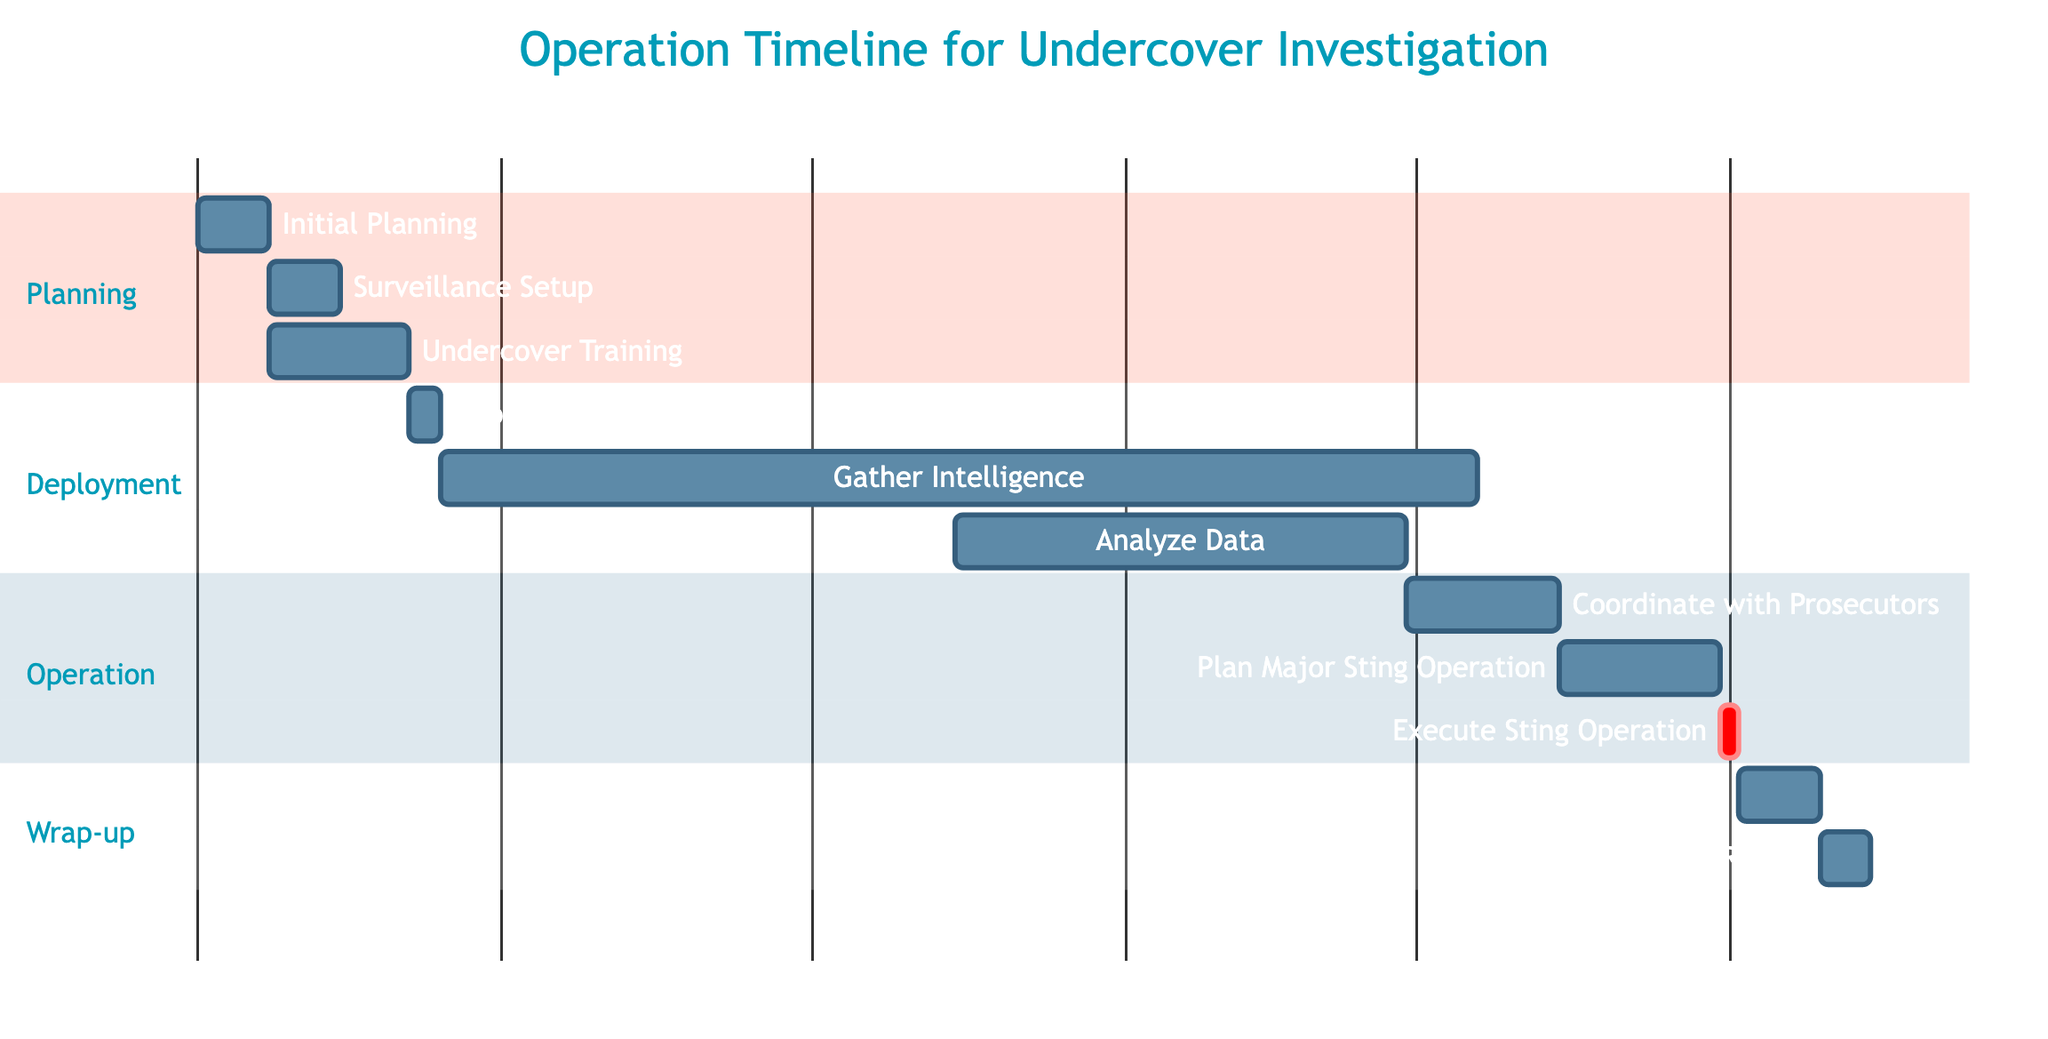What's the duration of the "Initial Planning" task? The "Initial Planning" task starts on November 1, 2023, and ends on November 7, 2023. The duration can be calculated as the difference between these two dates, which is 7 days.
Answer: 7 days Which task follows "Deploy Informant"? The task that follows "Deploy Informant" is "Gather Intelligence". In the Gantt chart, "Gather Intelligence" begins immediately after "Deploy Informant" concludes.
Answer: Gather Intelligence How many total tasks are there in the Gantt chart? By counting the listed tasks in the Gantt chart, we can see that there are 11 tasks displayed in total.
Answer: 11 tasks What is the end date of the "Execute Sting Operation"? The "Execute Sting Operation" task starts on April 1, 2024, and ends on April 2, 2024. Therefore, the end date can be determined directly from the task information.
Answer: April 2, 2024 Which task requires the "Gather Intelligence" task to be completed before it can start? The task that requires "Gather Intelligence" to be completed is "Analyze Data". The dependency shown in the Gantt chart indicates that "Analyze Data" cannot begin until "Gather Intelligence" is finished.
Answer: Analyze Data What is the total duration of the "Operation" section? The "Operation" section contains three tasks: "Coordinate with Prosecutors" (15 days), "Plan Major Sting Operation" (16 days), and "Execute Sting Operation" (2 days). The total duration can be calculated by summing these durations, which gives a total of 33 days.
Answer: 33 days What day does the "File Final Report" task start? The "File Final Report" task begins on April 11, 2024, as indicated in the chart. The start date is explicitly noted for this task, making it easy to identify.
Answer: April 11, 2024 How many days does the "Gather Intelligence" task last? The "Gather Intelligence" task starts on November 18, 2023, and ends on February 28, 2024. To find the duration, we count the days from the start to the end date, resulting in 103 days.
Answer: 103 days What is the immediate predecessor of the "Post-Operation Review"? "Post-Operation Review" is immediately preceded by "Execute Sting Operation". The Gantt chart shows that "Post-Operation Review" starts right after the completion of "Execute Sting Operation".
Answer: Execute Sting Operation 